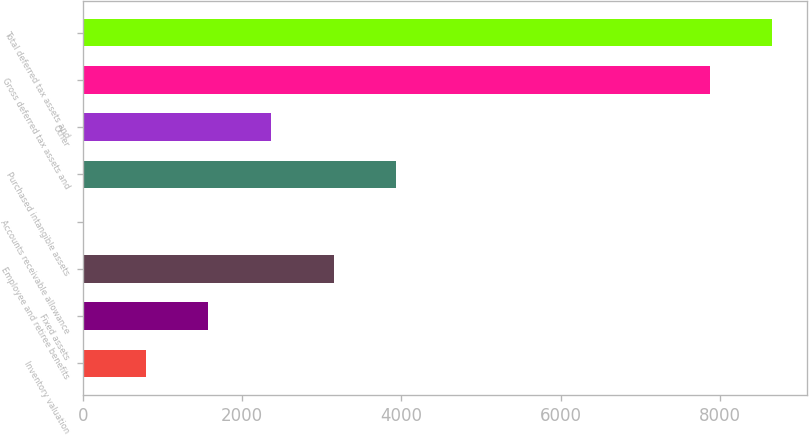Convert chart. <chart><loc_0><loc_0><loc_500><loc_500><bar_chart><fcel>Inventory valuation<fcel>Fixed assets<fcel>Employee and retiree benefits<fcel>Accounts receivable allowance<fcel>Purchased intangible assets<fcel>Other<fcel>Gross deferred tax assets and<fcel>Total deferred tax assets and<nl><fcel>789.4<fcel>1575.8<fcel>3148.6<fcel>3<fcel>3935<fcel>2362.2<fcel>7867<fcel>8653.4<nl></chart> 